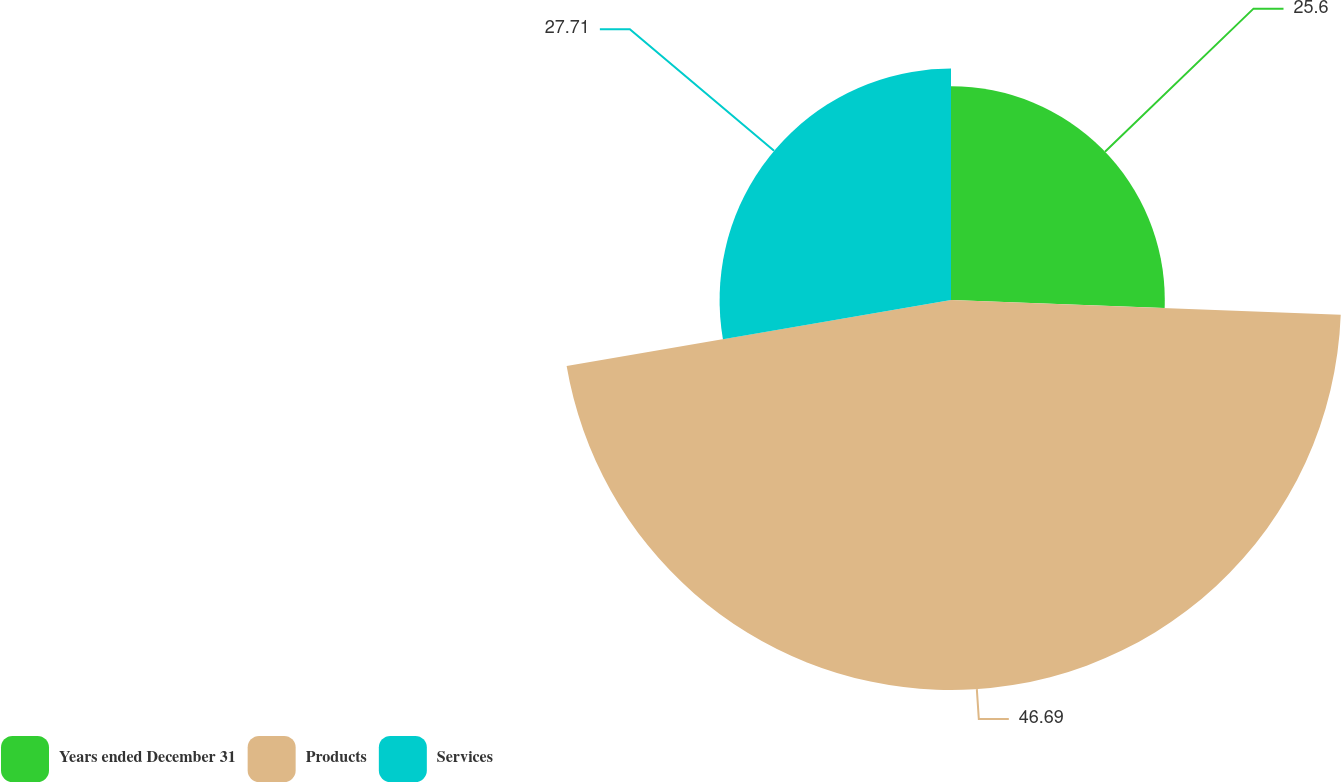<chart> <loc_0><loc_0><loc_500><loc_500><pie_chart><fcel>Years ended December 31<fcel>Products<fcel>Services<nl><fcel>25.6%<fcel>46.7%<fcel>27.71%<nl></chart> 